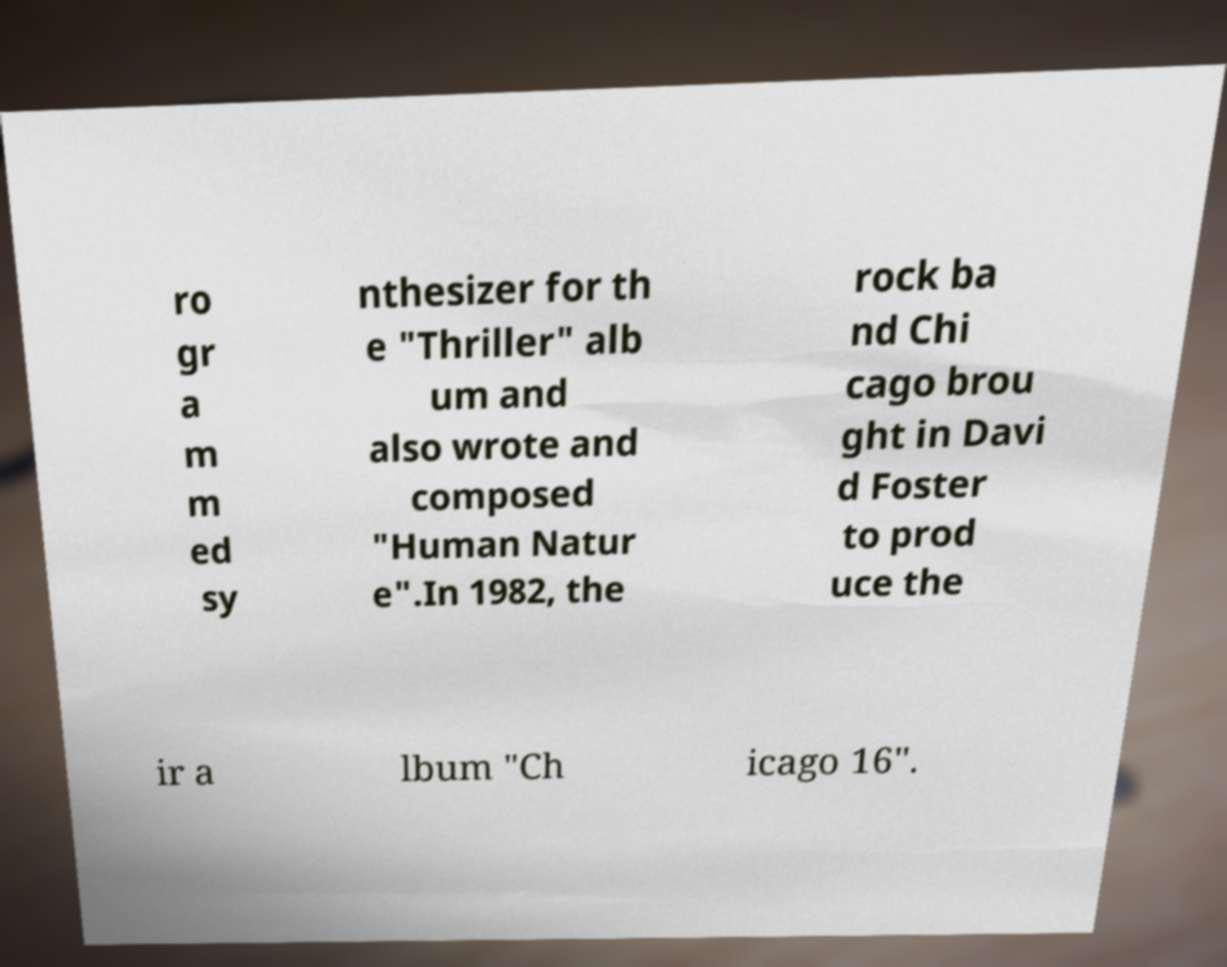There's text embedded in this image that I need extracted. Can you transcribe it verbatim? ro gr a m m ed sy nthesizer for th e "Thriller" alb um and also wrote and composed "Human Natur e".In 1982, the rock ba nd Chi cago brou ght in Davi d Foster to prod uce the ir a lbum "Ch icago 16". 